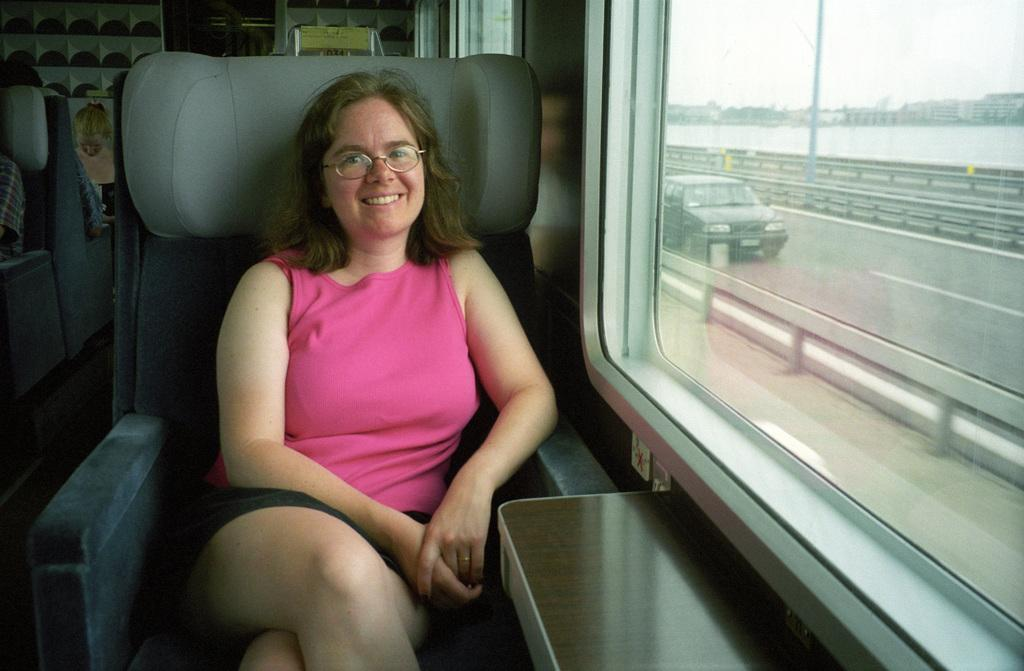Who is present in the image? There is a woman in the image. What is the woman doing in the image? The woman is sitting on a chair. What is the woman's facial expression in the image? The woman is smiling. What accessory is the woman wearing in the image? The woman is wearing spectacles. What type of image is this? The image is a poster. What type of engine can be seen in the image? There is no engine visible in the image; it is a poster featuring a woman sitting on a chair. What type of hall is depicted in the image? There is no hall depicted in the image; it is a poster featuring a woman sitting on a chair with a view through a glass window. 